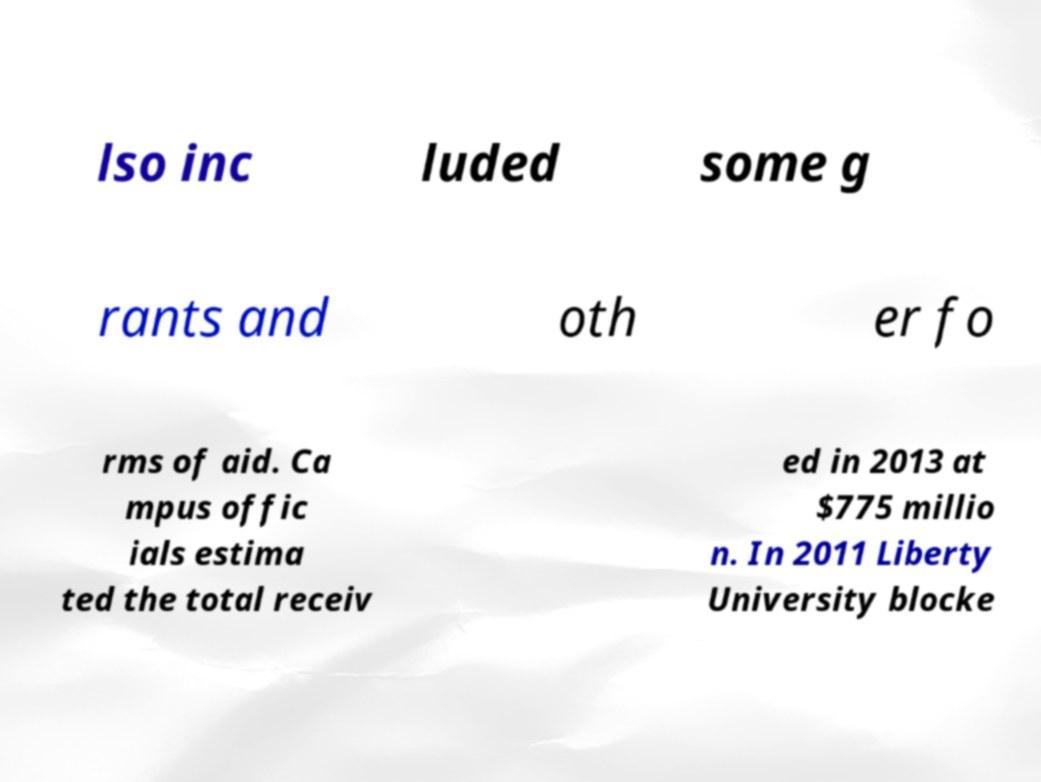Please identify and transcribe the text found in this image. lso inc luded some g rants and oth er fo rms of aid. Ca mpus offic ials estima ted the total receiv ed in 2013 at $775 millio n. In 2011 Liberty University blocke 